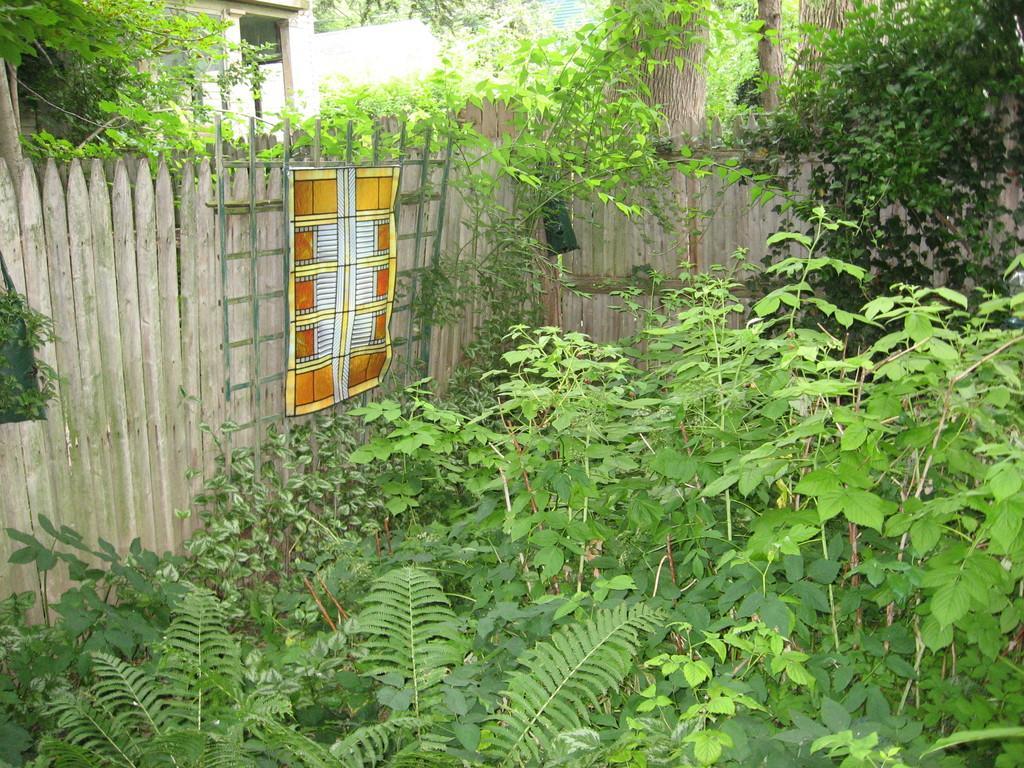Describe this image in one or two sentences. In this image, we can see some plants and trees, we can see the wooden fence. 